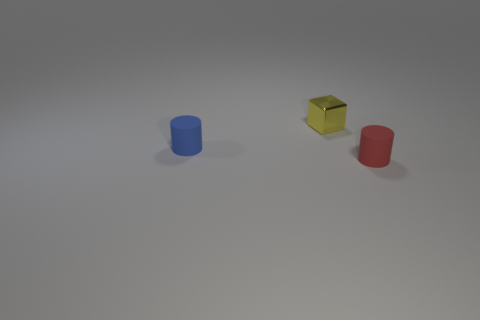Is the number of small purple metal cylinders less than the number of tiny shiny blocks?
Offer a terse response. Yes. How many other things are made of the same material as the tiny cube?
Give a very brief answer. 0. The blue object that is the same shape as the red thing is what size?
Give a very brief answer. Small. Is the material of the cylinder to the left of the small yellow metallic cube the same as the red object on the right side of the small metallic object?
Make the answer very short. Yes. Are there fewer small red rubber objects in front of the tiny red cylinder than large brown rubber cylinders?
Offer a very short reply. No. Is there any other thing that is the same shape as the blue rubber thing?
Make the answer very short. Yes. The other tiny thing that is the same shape as the red matte thing is what color?
Make the answer very short. Blue. There is a cylinder that is in front of the blue matte cylinder; is it the same size as the small yellow block?
Ensure brevity in your answer.  Yes. There is a matte thing that is to the right of the matte cylinder that is to the left of the red thing; how big is it?
Keep it short and to the point. Small. Is the material of the small yellow thing the same as the cylinder on the right side of the tiny blue cylinder?
Offer a very short reply. No. 